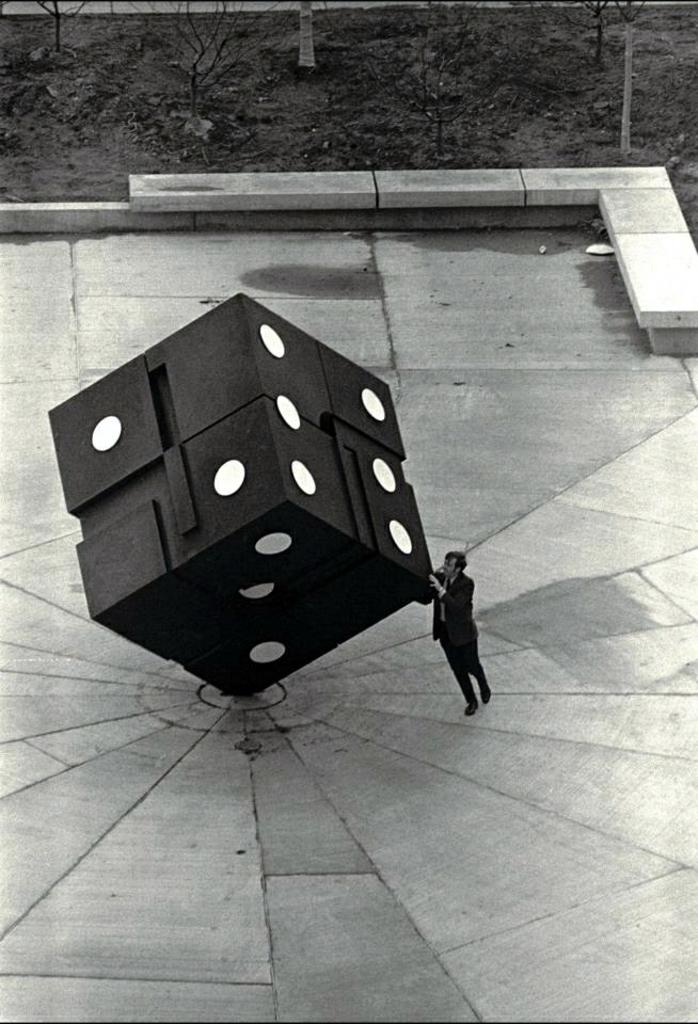What is the shape of the architecture in the image? The architecture in the image is dice-shaped. Where is the architecture located? The architecture is on the ground. Is there anyone else in the image besides the architecture? Yes, there is a man standing in the image. What can be seen in the background of the image? There are trees visible in the image. What type of polish is the man applying to the architecture in the image? There is no indication in the image that the man is applying any polish to the architecture. 